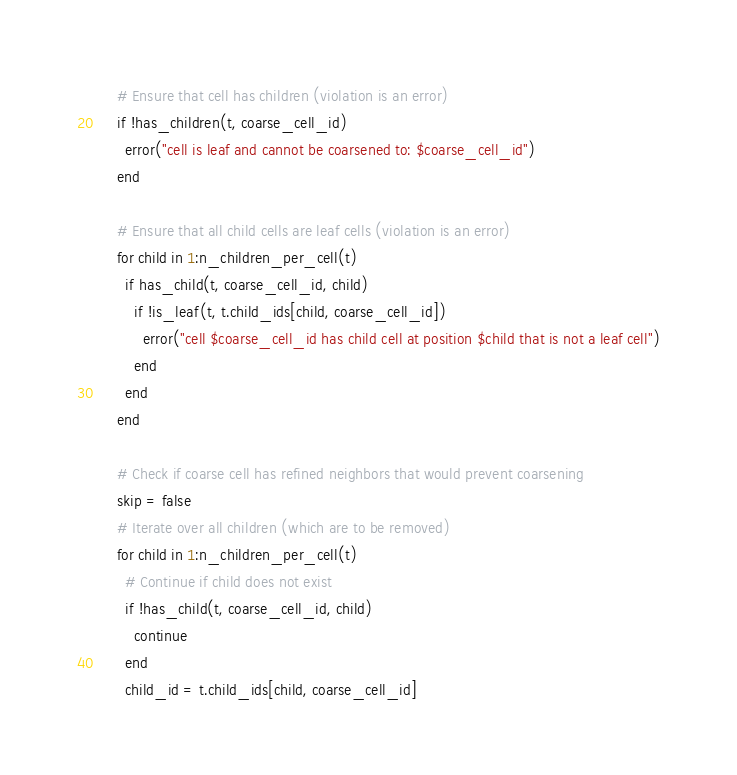Convert code to text. <code><loc_0><loc_0><loc_500><loc_500><_Julia_>    # Ensure that cell has children (violation is an error)
    if !has_children(t, coarse_cell_id)
      error("cell is leaf and cannot be coarsened to: $coarse_cell_id")
    end

    # Ensure that all child cells are leaf cells (violation is an error)
    for child in 1:n_children_per_cell(t)
      if has_child(t, coarse_cell_id, child)
        if !is_leaf(t, t.child_ids[child, coarse_cell_id])
          error("cell $coarse_cell_id has child cell at position $child that is not a leaf cell")
        end
      end
    end

    # Check if coarse cell has refined neighbors that would prevent coarsening
    skip = false
    # Iterate over all children (which are to be removed)
    for child in 1:n_children_per_cell(t)
      # Continue if child does not exist
      if !has_child(t, coarse_cell_id, child)
        continue
      end
      child_id = t.child_ids[child, coarse_cell_id]
</code> 